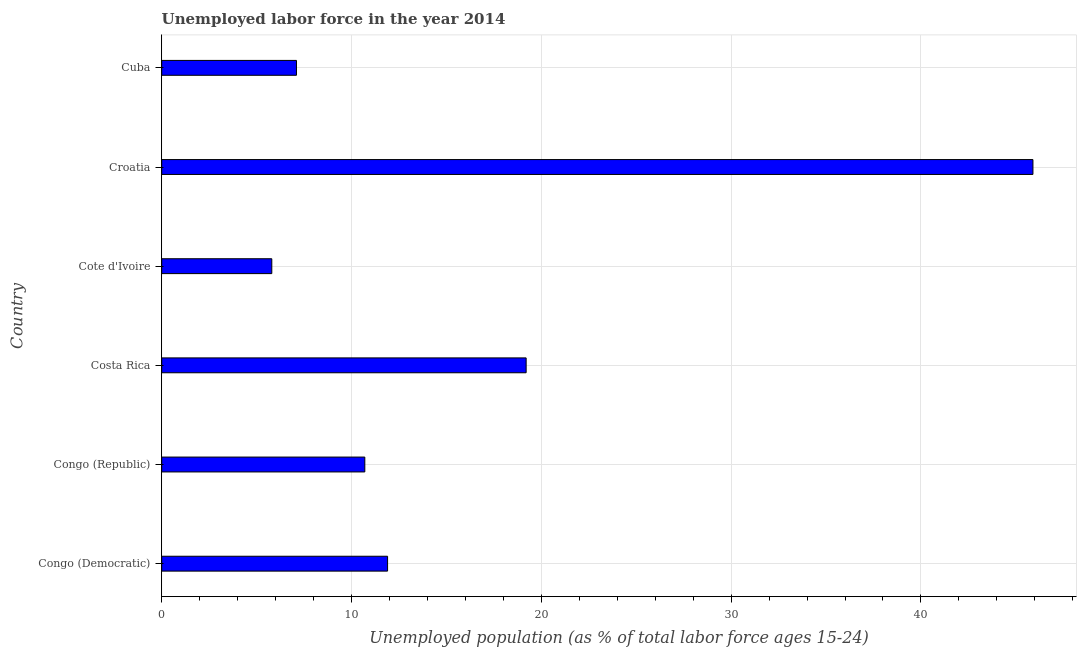Does the graph contain grids?
Offer a very short reply. Yes. What is the title of the graph?
Your answer should be compact. Unemployed labor force in the year 2014. What is the label or title of the X-axis?
Your answer should be compact. Unemployed population (as % of total labor force ages 15-24). What is the label or title of the Y-axis?
Provide a short and direct response. Country. What is the total unemployed youth population in Cuba?
Your answer should be very brief. 7.1. Across all countries, what is the maximum total unemployed youth population?
Offer a terse response. 45.9. Across all countries, what is the minimum total unemployed youth population?
Offer a very short reply. 5.8. In which country was the total unemployed youth population maximum?
Your response must be concise. Croatia. In which country was the total unemployed youth population minimum?
Give a very brief answer. Cote d'Ivoire. What is the sum of the total unemployed youth population?
Your answer should be compact. 100.6. What is the difference between the total unemployed youth population in Congo (Republic) and Croatia?
Make the answer very short. -35.2. What is the average total unemployed youth population per country?
Give a very brief answer. 16.77. What is the median total unemployed youth population?
Make the answer very short. 11.3. What is the ratio of the total unemployed youth population in Cote d'Ivoire to that in Croatia?
Give a very brief answer. 0.13. Is the difference between the total unemployed youth population in Congo (Democratic) and Cote d'Ivoire greater than the difference between any two countries?
Ensure brevity in your answer.  No. What is the difference between the highest and the second highest total unemployed youth population?
Make the answer very short. 26.7. What is the difference between the highest and the lowest total unemployed youth population?
Keep it short and to the point. 40.1. How many bars are there?
Ensure brevity in your answer.  6. Are all the bars in the graph horizontal?
Your answer should be compact. Yes. How many countries are there in the graph?
Offer a terse response. 6. Are the values on the major ticks of X-axis written in scientific E-notation?
Offer a very short reply. No. What is the Unemployed population (as % of total labor force ages 15-24) in Congo (Democratic)?
Provide a short and direct response. 11.9. What is the Unemployed population (as % of total labor force ages 15-24) in Congo (Republic)?
Make the answer very short. 10.7. What is the Unemployed population (as % of total labor force ages 15-24) in Costa Rica?
Offer a terse response. 19.2. What is the Unemployed population (as % of total labor force ages 15-24) of Cote d'Ivoire?
Ensure brevity in your answer.  5.8. What is the Unemployed population (as % of total labor force ages 15-24) of Croatia?
Provide a short and direct response. 45.9. What is the Unemployed population (as % of total labor force ages 15-24) in Cuba?
Your answer should be compact. 7.1. What is the difference between the Unemployed population (as % of total labor force ages 15-24) in Congo (Democratic) and Congo (Republic)?
Your answer should be compact. 1.2. What is the difference between the Unemployed population (as % of total labor force ages 15-24) in Congo (Democratic) and Cote d'Ivoire?
Ensure brevity in your answer.  6.1. What is the difference between the Unemployed population (as % of total labor force ages 15-24) in Congo (Democratic) and Croatia?
Ensure brevity in your answer.  -34. What is the difference between the Unemployed population (as % of total labor force ages 15-24) in Congo (Republic) and Cote d'Ivoire?
Give a very brief answer. 4.9. What is the difference between the Unemployed population (as % of total labor force ages 15-24) in Congo (Republic) and Croatia?
Offer a terse response. -35.2. What is the difference between the Unemployed population (as % of total labor force ages 15-24) in Costa Rica and Croatia?
Keep it short and to the point. -26.7. What is the difference between the Unemployed population (as % of total labor force ages 15-24) in Costa Rica and Cuba?
Provide a succinct answer. 12.1. What is the difference between the Unemployed population (as % of total labor force ages 15-24) in Cote d'Ivoire and Croatia?
Provide a succinct answer. -40.1. What is the difference between the Unemployed population (as % of total labor force ages 15-24) in Cote d'Ivoire and Cuba?
Your response must be concise. -1.3. What is the difference between the Unemployed population (as % of total labor force ages 15-24) in Croatia and Cuba?
Offer a terse response. 38.8. What is the ratio of the Unemployed population (as % of total labor force ages 15-24) in Congo (Democratic) to that in Congo (Republic)?
Keep it short and to the point. 1.11. What is the ratio of the Unemployed population (as % of total labor force ages 15-24) in Congo (Democratic) to that in Costa Rica?
Your answer should be compact. 0.62. What is the ratio of the Unemployed population (as % of total labor force ages 15-24) in Congo (Democratic) to that in Cote d'Ivoire?
Your answer should be very brief. 2.05. What is the ratio of the Unemployed population (as % of total labor force ages 15-24) in Congo (Democratic) to that in Croatia?
Provide a succinct answer. 0.26. What is the ratio of the Unemployed population (as % of total labor force ages 15-24) in Congo (Democratic) to that in Cuba?
Provide a short and direct response. 1.68. What is the ratio of the Unemployed population (as % of total labor force ages 15-24) in Congo (Republic) to that in Costa Rica?
Provide a short and direct response. 0.56. What is the ratio of the Unemployed population (as % of total labor force ages 15-24) in Congo (Republic) to that in Cote d'Ivoire?
Your answer should be very brief. 1.84. What is the ratio of the Unemployed population (as % of total labor force ages 15-24) in Congo (Republic) to that in Croatia?
Offer a terse response. 0.23. What is the ratio of the Unemployed population (as % of total labor force ages 15-24) in Congo (Republic) to that in Cuba?
Your answer should be very brief. 1.51. What is the ratio of the Unemployed population (as % of total labor force ages 15-24) in Costa Rica to that in Cote d'Ivoire?
Give a very brief answer. 3.31. What is the ratio of the Unemployed population (as % of total labor force ages 15-24) in Costa Rica to that in Croatia?
Your answer should be compact. 0.42. What is the ratio of the Unemployed population (as % of total labor force ages 15-24) in Costa Rica to that in Cuba?
Provide a succinct answer. 2.7. What is the ratio of the Unemployed population (as % of total labor force ages 15-24) in Cote d'Ivoire to that in Croatia?
Ensure brevity in your answer.  0.13. What is the ratio of the Unemployed population (as % of total labor force ages 15-24) in Cote d'Ivoire to that in Cuba?
Your response must be concise. 0.82. What is the ratio of the Unemployed population (as % of total labor force ages 15-24) in Croatia to that in Cuba?
Your response must be concise. 6.46. 